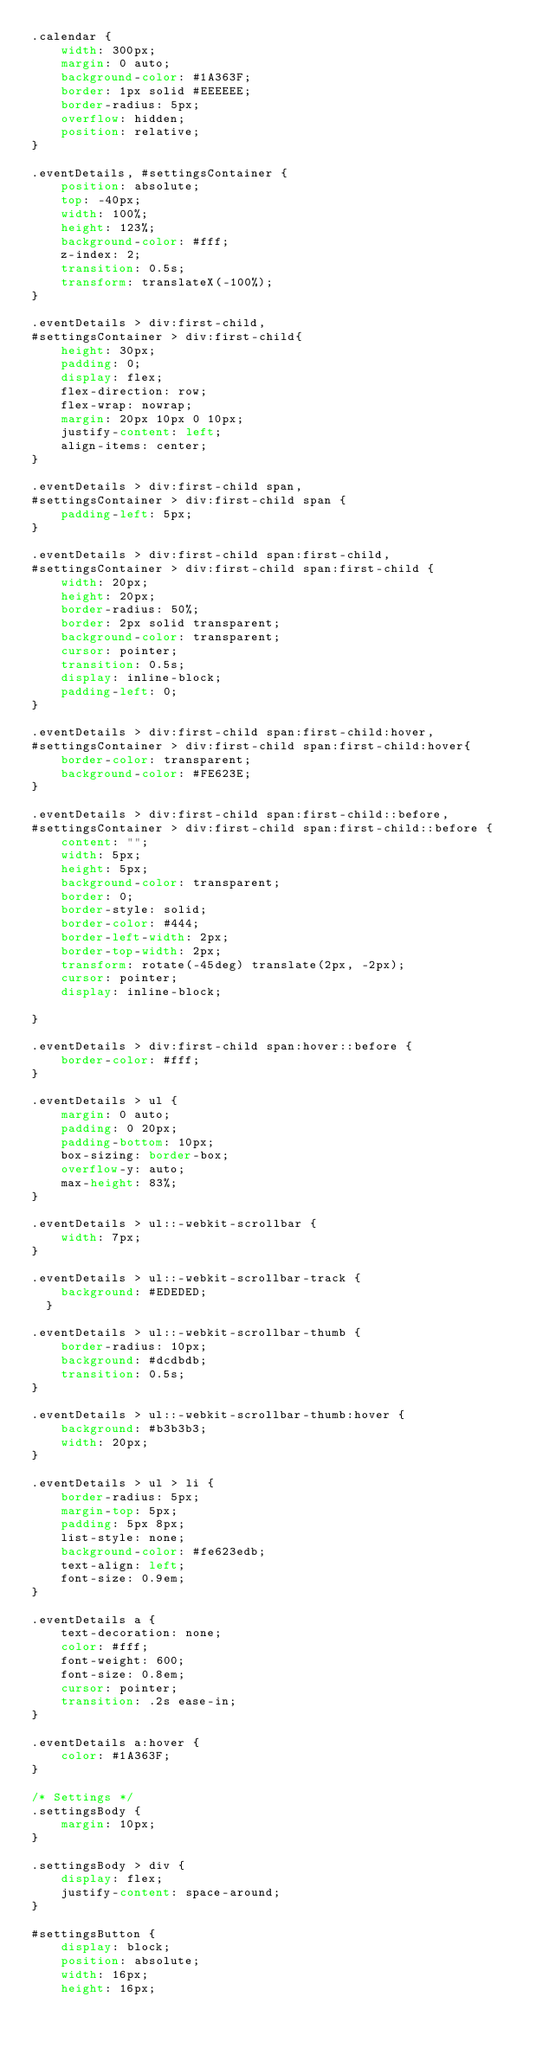<code> <loc_0><loc_0><loc_500><loc_500><_CSS_>.calendar {
    width: 300px;
    margin: 0 auto;
    background-color: #1A363F;
    border: 1px solid #EEEEEE;
    border-radius: 5px;
    overflow: hidden;
    position: relative;
}

.eventDetails, #settingsContainer {
    position: absolute;
    top: -40px;
    width: 100%;
    height: 123%;
    background-color: #fff;
    z-index: 2;
    transition: 0.5s;
    transform: translateX(-100%);
}

.eventDetails > div:first-child,
#settingsContainer > div:first-child{
    height: 30px;
    padding: 0;
    display: flex;
    flex-direction: row;
    flex-wrap: nowrap;
    margin: 20px 10px 0 10px;
    justify-content: left;
    align-items: center;
}

.eventDetails > div:first-child span,
#settingsContainer > div:first-child span {
    padding-left: 5px;
}

.eventDetails > div:first-child span:first-child,
#settingsContainer > div:first-child span:first-child {
    width: 20px;
    height: 20px;
    border-radius: 50%;
    border: 2px solid transparent;
    background-color: transparent;
    cursor: pointer;
    transition: 0.5s;
    display: inline-block;
    padding-left: 0;
}

.eventDetails > div:first-child span:first-child:hover,
#settingsContainer > div:first-child span:first-child:hover{
    border-color: transparent;
    background-color: #FE623E;
}

.eventDetails > div:first-child span:first-child::before,
#settingsContainer > div:first-child span:first-child::before {
    content: "";
    width: 5px;
    height: 5px;
    background-color: transparent;
    border: 0;
    border-style: solid;
    border-color: #444;
    border-left-width: 2px;
    border-top-width: 2px;
    transform: rotate(-45deg) translate(2px, -2px);
    cursor: pointer;
    display: inline-block;

}

.eventDetails > div:first-child span:hover::before {
    border-color: #fff;
}

.eventDetails > ul {
    margin: 0 auto;
    padding: 0 20px;
    padding-bottom: 10px;
    box-sizing: border-box;
    overflow-y: auto;
    max-height: 83%;
}

.eventDetails > ul::-webkit-scrollbar {
    width: 7px;
}

.eventDetails > ul::-webkit-scrollbar-track {
    background: #EDEDED;
  }

.eventDetails > ul::-webkit-scrollbar-thumb {
    border-radius: 10px;
    background: #dcdbdb;
    transition: 0.5s;
}

.eventDetails > ul::-webkit-scrollbar-thumb:hover {
    background: #b3b3b3;
    width: 20px;
}

.eventDetails > ul > li {
    border-radius: 5px;
    margin-top: 5px;
    padding: 5px 8px;
    list-style: none;
    background-color: #fe623edb;
    text-align: left;
    font-size: 0.9em;
}

.eventDetails a {
    text-decoration: none;
    color: #fff;
    font-weight: 600;
    font-size: 0.8em;
    cursor: pointer;
    transition: .2s ease-in;
}

.eventDetails a:hover {
    color: #1A363F;
}

/* Settings */
.settingsBody {
    margin: 10px;
}

.settingsBody > div {
    display: flex;
    justify-content: space-around;
}

#settingsButton {
    display: block;
    position: absolute;
    width: 16px;
    height: 16px;</code> 